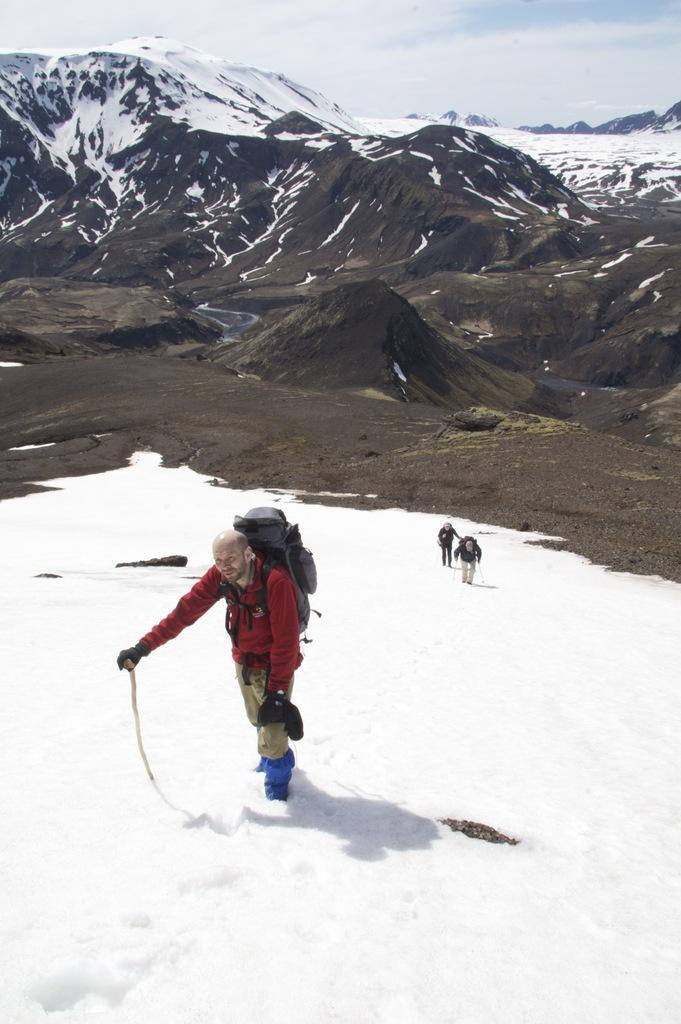What is the weather condition in the image? The sky is cloudy in the image. What can be seen on the ground in the image? There is snow in the image. What are the people in the image doing? There is a man holding a stick in the image. What is the man wearing in the image? The man is wearing a bag in the image. What type of plate is being used to serve the cakes in the image? There are no cakes or plates present in the image. What kind of experience can be gained from the image? The image does not depict an experience; it is a static representation of a scene. 